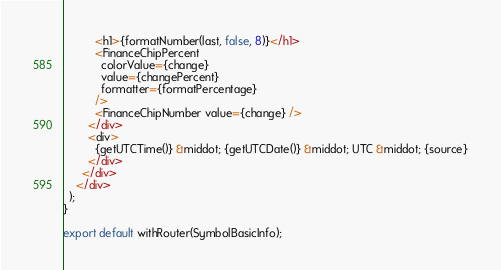Convert code to text. <code><loc_0><loc_0><loc_500><loc_500><_TypeScript_>          <h1>{formatNumber(last, false, 8)}</h1>
          <FinanceChipPercent
            colorValue={change}
            value={changePercent}
            formatter={formatPercentage}
          />
          <FinanceChipNumber value={change} />
        </div>
        <div>
          {getUTCTime()} &middot; {getUTCDate()} &middot; UTC &middot; {source}
        </div>
      </div>
    </div>
  );
}

export default withRouter(SymbolBasicInfo);
</code> 